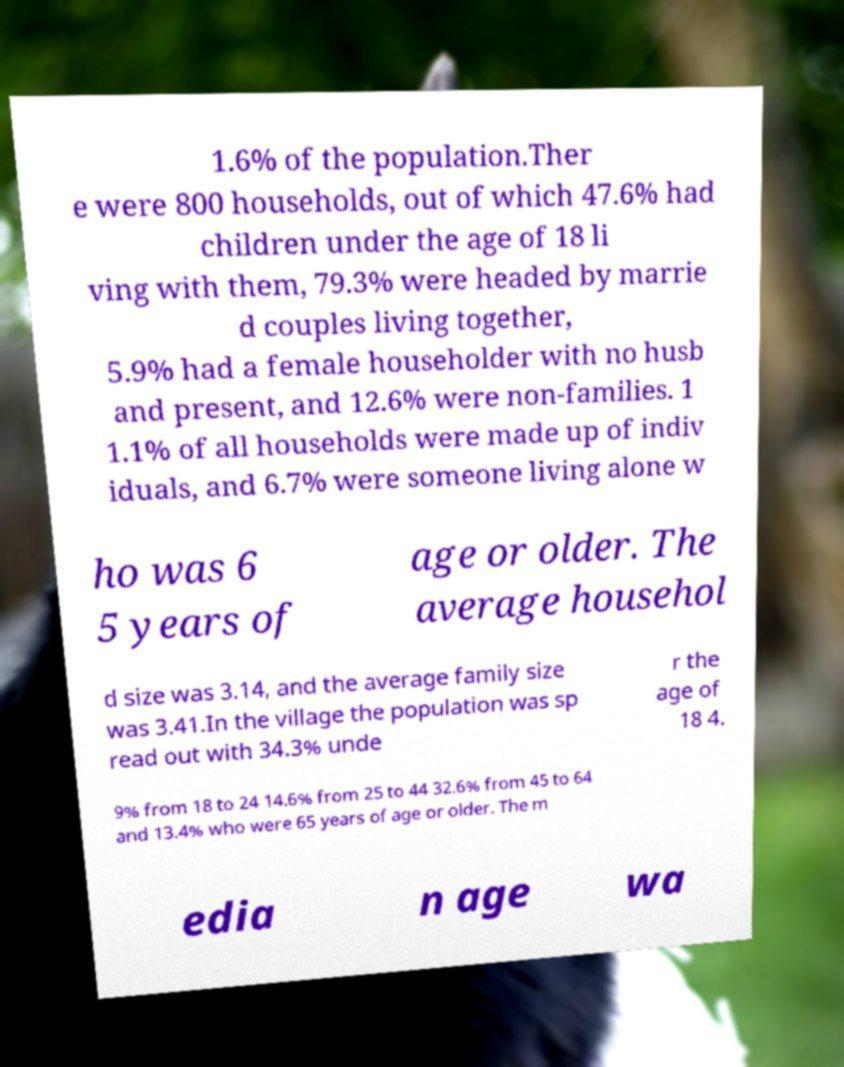Please identify and transcribe the text found in this image. 1.6% of the population.Ther e were 800 households, out of which 47.6% had children under the age of 18 li ving with them, 79.3% were headed by marrie d couples living together, 5.9% had a female householder with no husb and present, and 12.6% were non-families. 1 1.1% of all households were made up of indiv iduals, and 6.7% were someone living alone w ho was 6 5 years of age or older. The average househol d size was 3.14, and the average family size was 3.41.In the village the population was sp read out with 34.3% unde r the age of 18 4. 9% from 18 to 24 14.6% from 25 to 44 32.6% from 45 to 64 and 13.4% who were 65 years of age or older. The m edia n age wa 